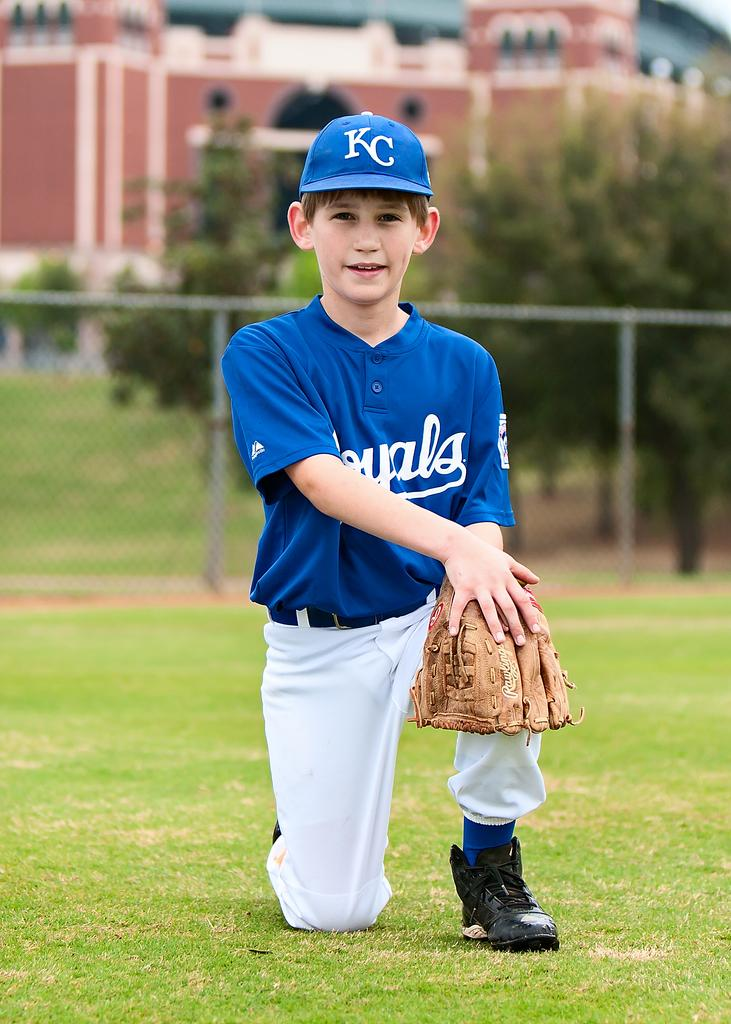<image>
Describe the image concisely. A boy in a KC Royals baseball uniform kneels on the field. 